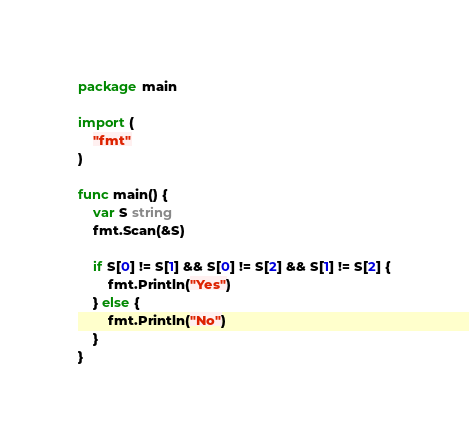<code> <loc_0><loc_0><loc_500><loc_500><_Go_>package main

import (
	"fmt"
)

func main() {
	var S string
	fmt.Scan(&S)

	if S[0] != S[1] && S[0] != S[2] && S[1] != S[2] {
		fmt.Println("Yes")
	} else {
		fmt.Println("No")
	}
}
</code> 